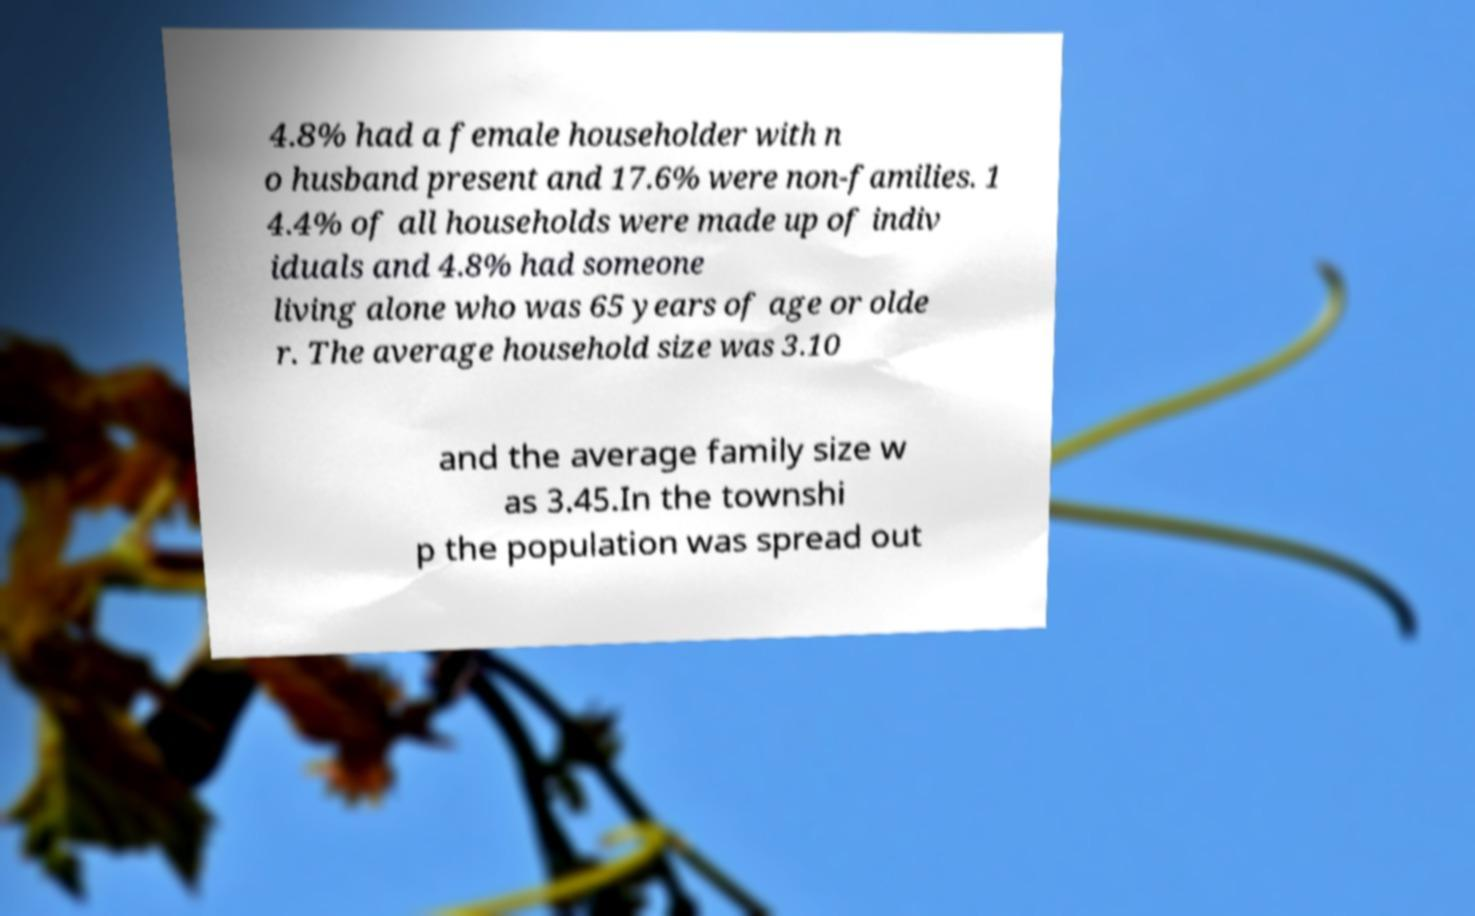For documentation purposes, I need the text within this image transcribed. Could you provide that? 4.8% had a female householder with n o husband present and 17.6% were non-families. 1 4.4% of all households were made up of indiv iduals and 4.8% had someone living alone who was 65 years of age or olde r. The average household size was 3.10 and the average family size w as 3.45.In the townshi p the population was spread out 